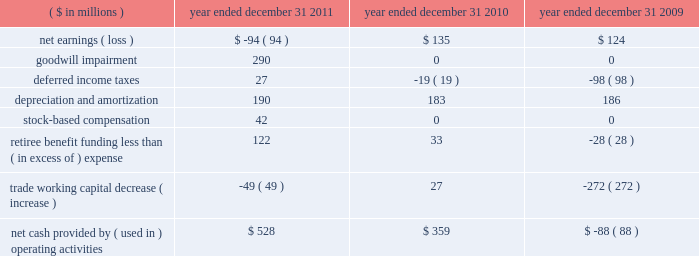Construction of cvn-79 john f .
Kennedy , construction of the u.s .
Coast guard 2019s fifth national security cutter ( unnamed ) , advance planning efforts for the cvn-72 uss abraham lincoln rcoh , and continued execution of the cvn-71 uss theodore roosevelt rcoh .
2010 2014the value of new contract awards during the year ended december 31 , 2010 , was approximately $ 3.6 billion .
Significant new awards during this period included $ 480 million for the construction of the u.s .
Coast guard 2019s fourth national security cutter hamilton , $ 480 million for design and long-lead material procurement activities for the cvn-79 john f .
Kennedy aircraft carrier , $ 377 million for cvn-78 gerald r .
Ford , $ 224 million for lha-7 ( unnamed ) , $ 184 million for lpd-26 john p .
Murtha , $ 114 million for ddg-114 ralph johnson and $ 62 million for long-lead material procurement activities for lpd-27 ( unnamed ) .
Liquidity and capital resources we endeavor to ensure the most efficient conversion of operating results into cash for deployment in operating our businesses and maximizing stockholder value .
We use various financial measures to assist in capital deployment decision making , including net cash provided by operating activities and free cash flow .
We believe these measures are useful to investors in assessing our financial performance .
The table below summarizes key components of cash flow provided by ( used in ) operating activities: .
Cash flows we discuss below our major operating , investing and financing activities for each of the three years in the period ended december 31 , 2011 , as classified on our consolidated statements of cash flows .
Operating activities 2011 2014cash provided by operating activities was $ 528 million in 2011 compared with $ 359 million in 2010 .
The increase of $ 169 million was due principally to increased earnings net of impairment charges and lower pension contributions , offset by an increase in trade working capital .
Net cash paid by northrop grumman on our behalf for u.s .
Federal income tax obligations was $ 53 million .
We expect cash generated from operations for 2012 to be sufficient to service debt , meet contract obligations , and finance capital expenditures .
Although 2012 cash from operations is expected to be sufficient to service these obligations , we may from time to time borrow funds under our credit facility to accommodate timing differences in cash flows .
2010 2014net cash provided by operating activities was $ 359 million in 2010 compared with cash used of $ 88 million in 2009 .
The change of $ 447 million was due principally to a decrease in discretionary pension contributions of $ 97 million , a decrease in trade working capital of $ 299 million , and a decrease in deferred income taxes of $ 79 million .
In 2009 , trade working capital balances included the unfavorable impact of delayed customer billings associated with the negative performance adjustments on the lpd-22 through lpd-25 contract due to projected cost increases at completion .
See note 7 : contract charges in item 8 .
The change in deferred taxes was due principally to the timing of contract related deductions .
U.s .
Federal income tax payments made by northrop grumman on our behalf were $ 89 million in 2010. .
What was the percentage change of the net cash provided by ( used in ) operating activities from 2009 to 2010? 
Rationale: there was a 507% increase in the net cash provided by net cash provided by ( used in ) operating activities from 2009 to 2010
Computations: ((359 - -88) / 88)
Answer: 5.07955. 